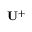Convert formula to latex. <formula><loc_0><loc_0><loc_500><loc_500>{ U } ^ { + }</formula> 